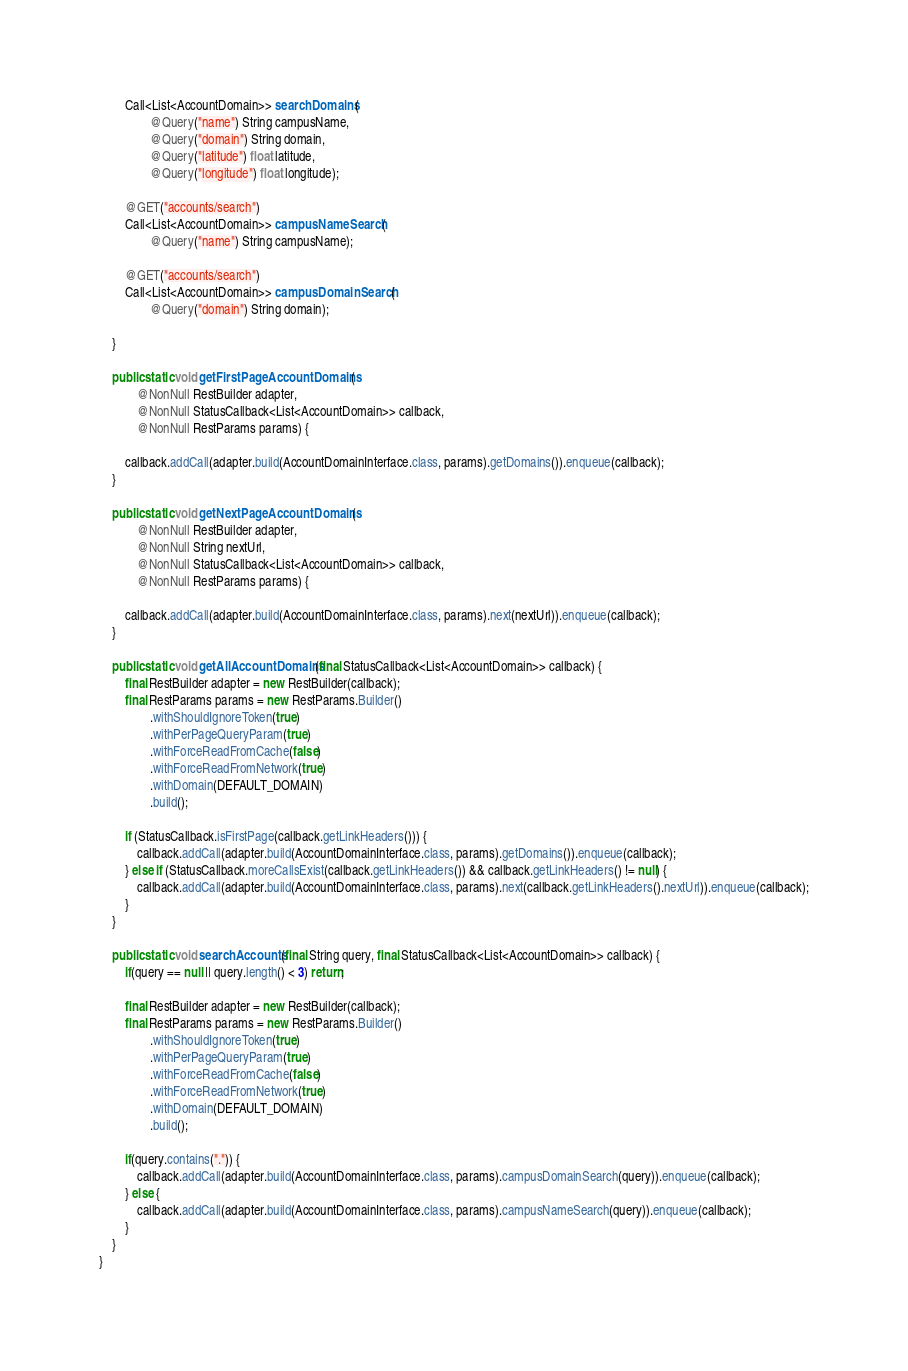Convert code to text. <code><loc_0><loc_0><loc_500><loc_500><_Java_>        Call<List<AccountDomain>> searchDomains(
                @Query("name") String campusName,
                @Query("domain") String domain,
                @Query("latitude") float latitude,
                @Query("longitude") float longitude);

        @GET("accounts/search")
        Call<List<AccountDomain>> campusNameSearch(
                @Query("name") String campusName);

        @GET("accounts/search")
        Call<List<AccountDomain>> campusDomainSearch(
                @Query("domain") String domain);

    }

    public static void getFirstPageAccountDomains(
            @NonNull RestBuilder adapter,
            @NonNull StatusCallback<List<AccountDomain>> callback,
            @NonNull RestParams params) {

        callback.addCall(adapter.build(AccountDomainInterface.class, params).getDomains()).enqueue(callback);
    }

    public static void getNextPageAccountDomains(
            @NonNull RestBuilder adapter,
            @NonNull String nextUrl,
            @NonNull StatusCallback<List<AccountDomain>> callback,
            @NonNull RestParams params) {

        callback.addCall(adapter.build(AccountDomainInterface.class, params).next(nextUrl)).enqueue(callback);
    }

    public static void getAllAccountDomains(final StatusCallback<List<AccountDomain>> callback) {
        final RestBuilder adapter = new RestBuilder(callback);
        final RestParams params = new RestParams.Builder()
                .withShouldIgnoreToken(true)
                .withPerPageQueryParam(true)
                .withForceReadFromCache(false)
                .withForceReadFromNetwork(true)
                .withDomain(DEFAULT_DOMAIN)
                .build();

        if (StatusCallback.isFirstPage(callback.getLinkHeaders())) {
            callback.addCall(adapter.build(AccountDomainInterface.class, params).getDomains()).enqueue(callback);
        } else if (StatusCallback.moreCallsExist(callback.getLinkHeaders()) && callback.getLinkHeaders() != null) {
            callback.addCall(adapter.build(AccountDomainInterface.class, params).next(callback.getLinkHeaders().nextUrl)).enqueue(callback);
        }
    }

    public static void searchAccounts(final String query, final StatusCallback<List<AccountDomain>> callback) {
        if(query == null || query.length() < 3) return;

        final RestBuilder adapter = new RestBuilder(callback);
        final RestParams params = new RestParams.Builder()
                .withShouldIgnoreToken(true)
                .withPerPageQueryParam(true)
                .withForceReadFromCache(false)
                .withForceReadFromNetwork(true)
                .withDomain(DEFAULT_DOMAIN)
                .build();

        if(query.contains(".")) {
            callback.addCall(adapter.build(AccountDomainInterface.class, params).campusDomainSearch(query)).enqueue(callback);
        } else {
            callback.addCall(adapter.build(AccountDomainInterface.class, params).campusNameSearch(query)).enqueue(callback);
        }
    }
}
</code> 